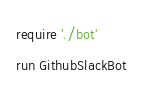Convert code to text. <code><loc_0><loc_0><loc_500><loc_500><_Ruby_>require './bot'
run GithubSlackBot
</code> 